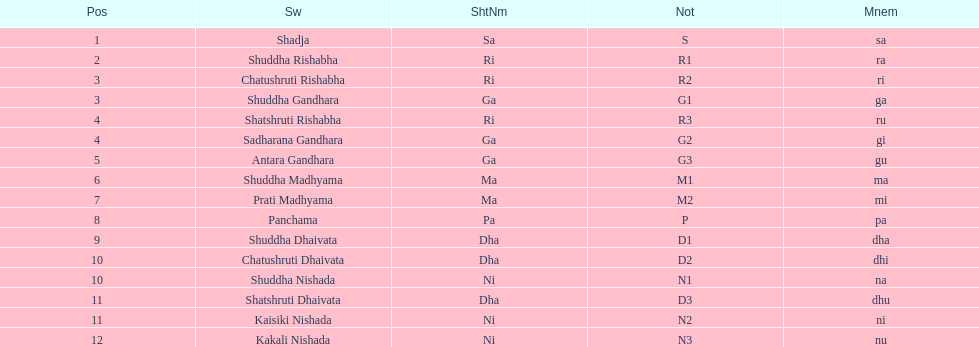List each pair of swaras that share the same position. Chatushruti Rishabha, Shuddha Gandhara, Shatshruti Rishabha, Sadharana Gandhara, Chatushruti Dhaivata, Shuddha Nishada, Shatshruti Dhaivata, Kaisiki Nishada. Parse the table in full. {'header': ['Pos', 'Sw', 'ShtNm', 'Not', 'Mnem'], 'rows': [['1', 'Shadja', 'Sa', 'S', 'sa'], ['2', 'Shuddha Rishabha', 'Ri', 'R1', 'ra'], ['3', 'Chatushruti Rishabha', 'Ri', 'R2', 'ri'], ['3', 'Shuddha Gandhara', 'Ga', 'G1', 'ga'], ['4', 'Shatshruti Rishabha', 'Ri', 'R3', 'ru'], ['4', 'Sadharana Gandhara', 'Ga', 'G2', 'gi'], ['5', 'Antara Gandhara', 'Ga', 'G3', 'gu'], ['6', 'Shuddha Madhyama', 'Ma', 'M1', 'ma'], ['7', 'Prati Madhyama', 'Ma', 'M2', 'mi'], ['8', 'Panchama', 'Pa', 'P', 'pa'], ['9', 'Shuddha Dhaivata', 'Dha', 'D1', 'dha'], ['10', 'Chatushruti Dhaivata', 'Dha', 'D2', 'dhi'], ['10', 'Shuddha Nishada', 'Ni', 'N1', 'na'], ['11', 'Shatshruti Dhaivata', 'Dha', 'D3', 'dhu'], ['11', 'Kaisiki Nishada', 'Ni', 'N2', 'ni'], ['12', 'Kakali Nishada', 'Ni', 'N3', 'nu']]} 